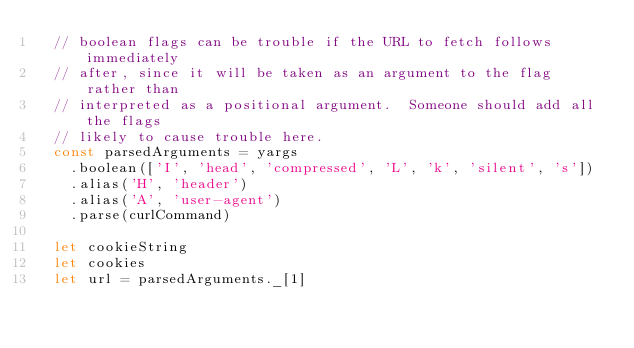Convert code to text. <code><loc_0><loc_0><loc_500><loc_500><_JavaScript_>  // boolean flags can be trouble if the URL to fetch follows immediately
  // after, since it will be taken as an argument to the flag rather than
  // interpreted as a positional argument.  Someone should add all the flags
  // likely to cause trouble here.
  const parsedArguments = yargs
    .boolean(['I', 'head', 'compressed', 'L', 'k', 'silent', 's'])
    .alias('H', 'header')
    .alias('A', 'user-agent')
    .parse(curlCommand)

  let cookieString
  let cookies
  let url = parsedArguments._[1]
</code> 